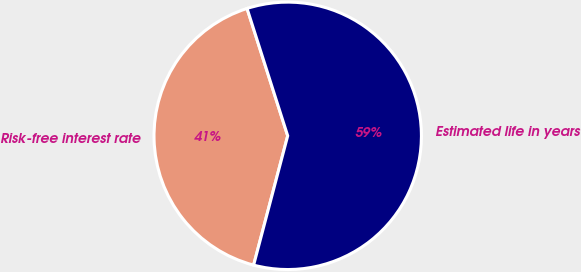<chart> <loc_0><loc_0><loc_500><loc_500><pie_chart><fcel>Risk-free interest rate<fcel>Estimated life in years<nl><fcel>40.98%<fcel>59.02%<nl></chart> 